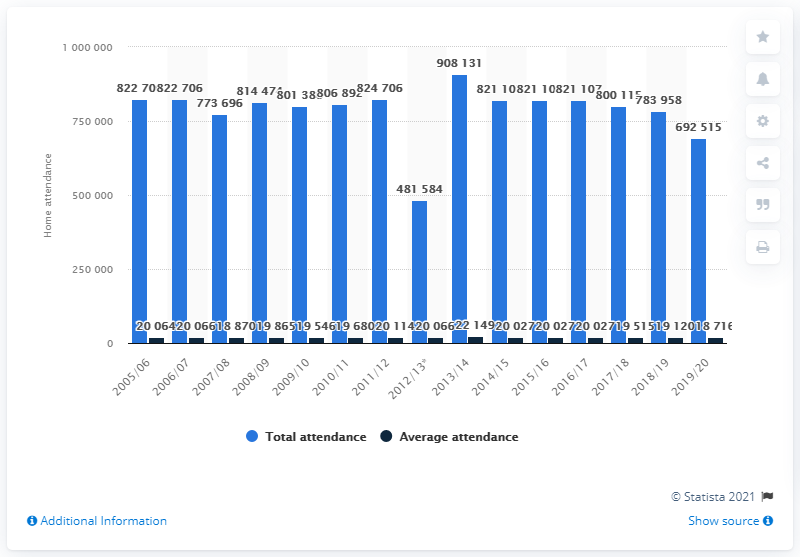Indicate a few pertinent items in this graphic. The last season of the Detroit Red Wings franchise in the National Hockey League was 2005/2006. 